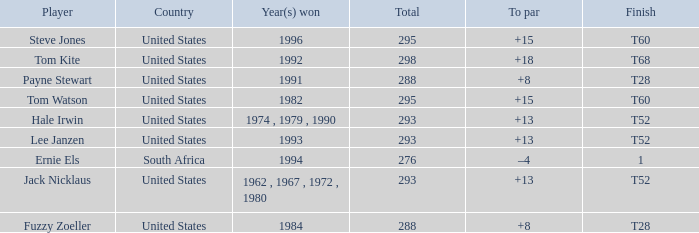What is the average total of player hale irwin, who had a t52 finish? 293.0. 